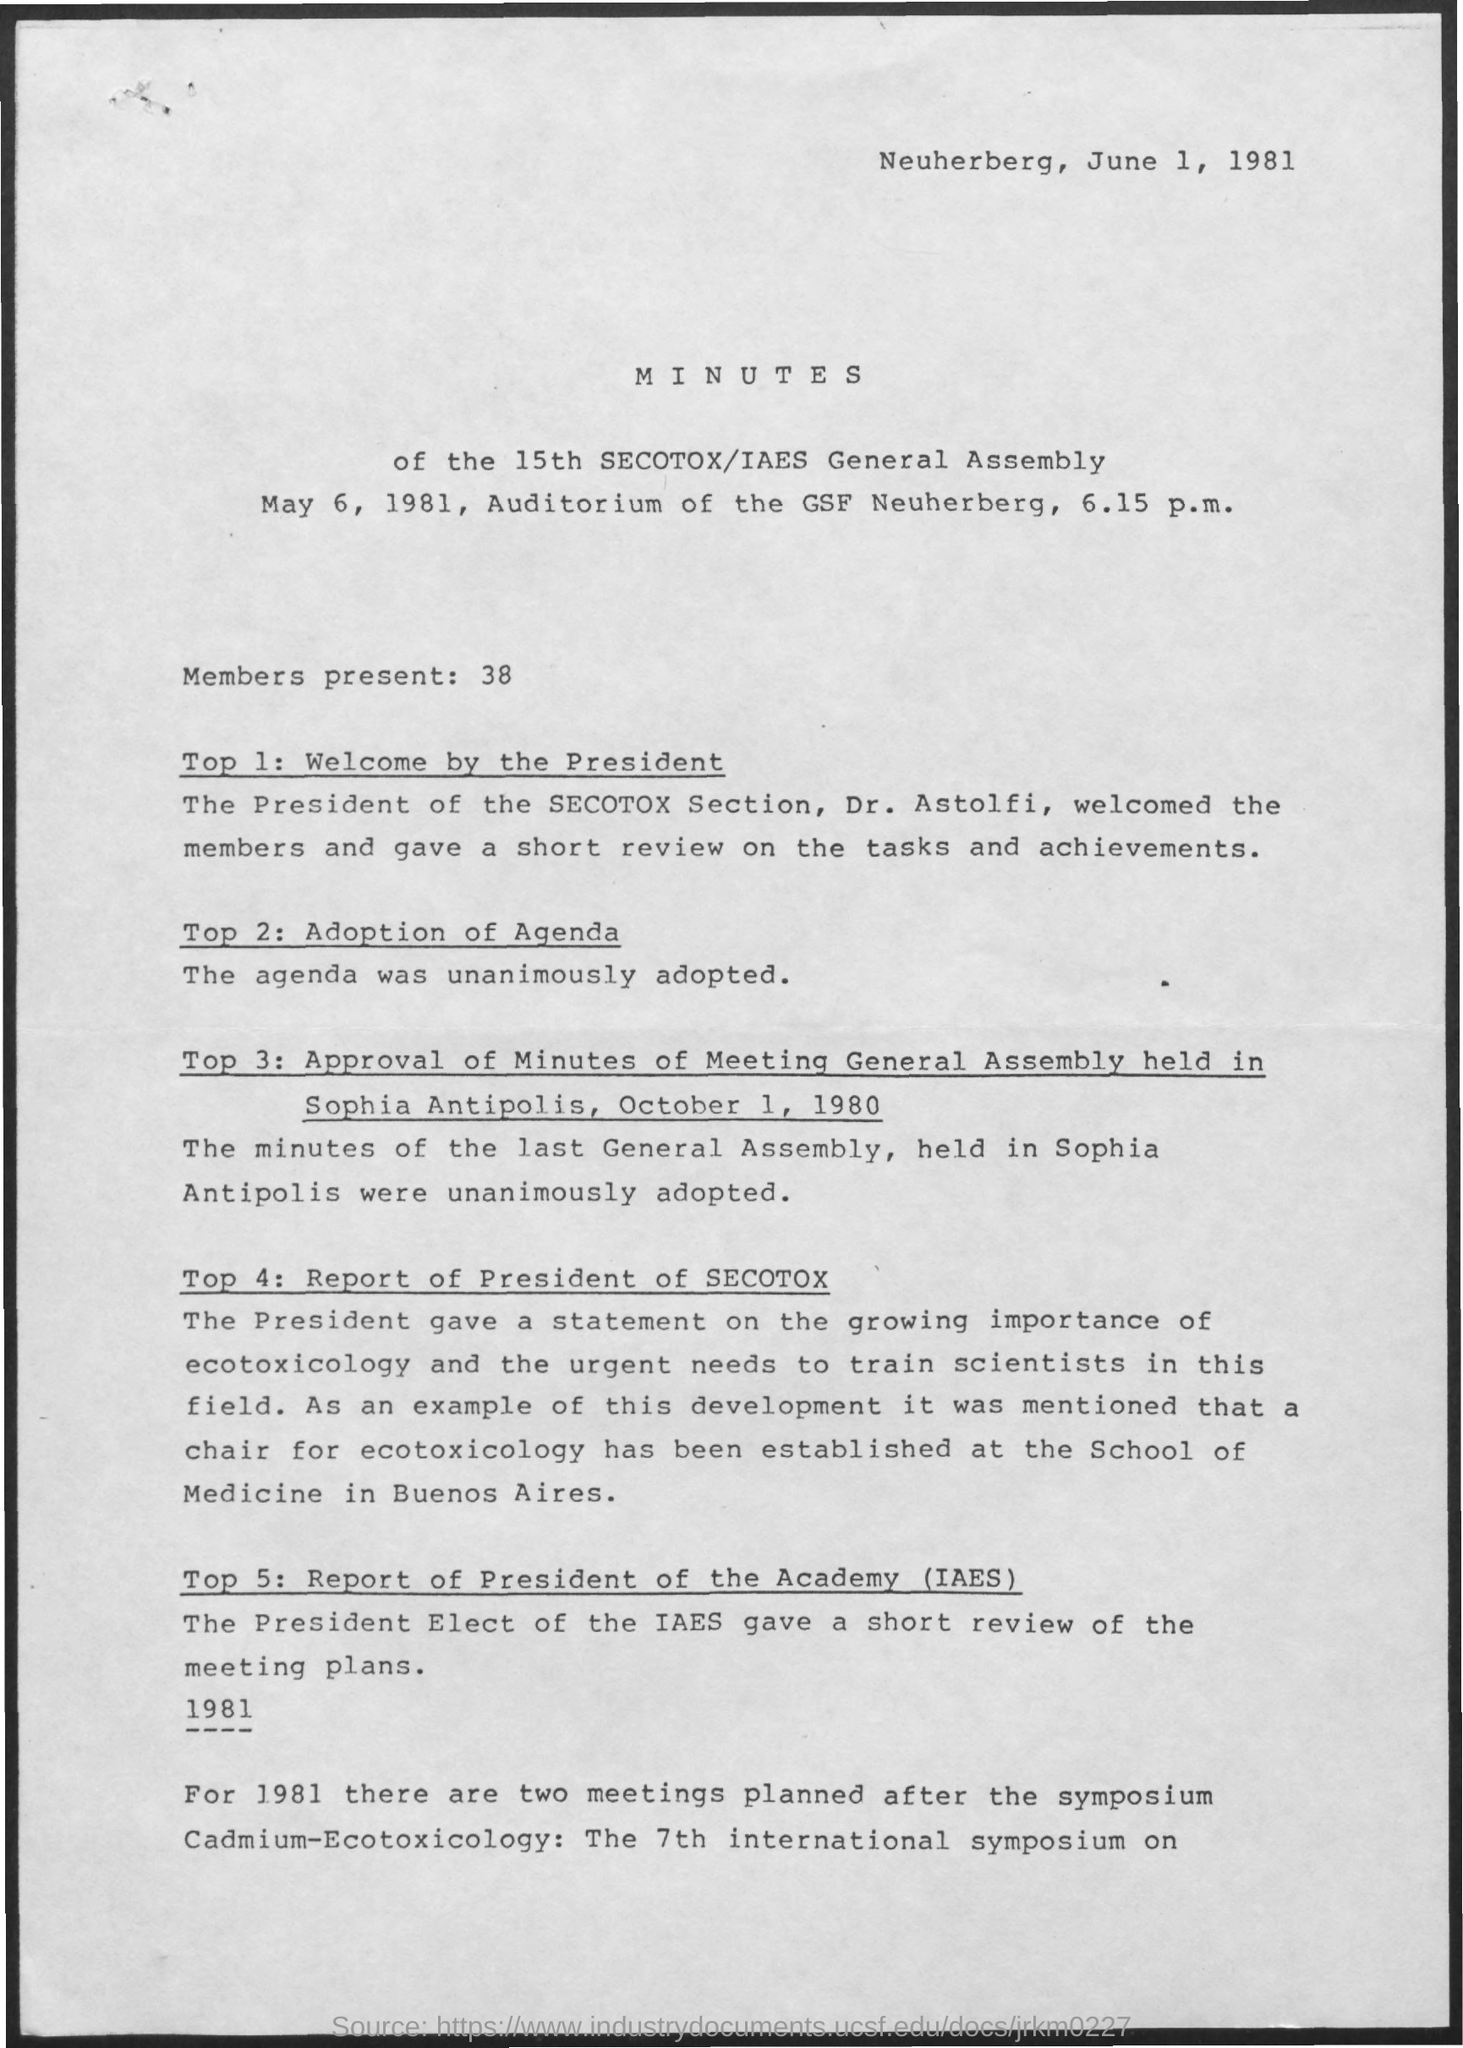Outline some significant characteristics in this image. Thirty-eight members were present. The general assembly was held on May 6, 1981. Dr. Astolfi is the President of the SECOTOX Section. The document is a record of the proceedings of the 15th General Assembly of SECOTOX/IAES, which includes minutes of the meeting. The document is dated June 1, 1981. 